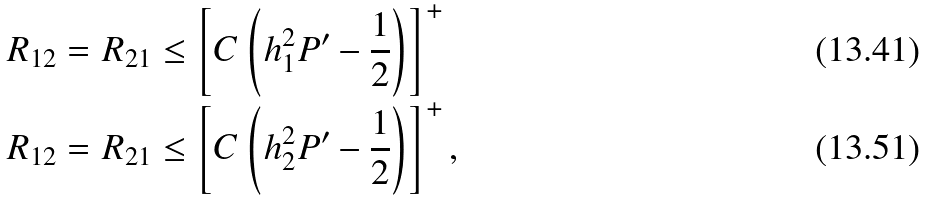Convert formula to latex. <formula><loc_0><loc_0><loc_500><loc_500>R _ { 1 2 } & = R _ { 2 1 } \leq \left [ C \left ( h _ { 1 } ^ { 2 } P ^ { \prime } - \frac { 1 } { 2 } \right ) \right ] ^ { + } \\ R _ { 1 2 } & = R _ { 2 1 } \leq \left [ C \left ( h _ { 2 } ^ { 2 } P ^ { \prime } - \frac { 1 } { 2 } \right ) \right ] ^ { + } ,</formula> 